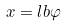Convert formula to latex. <formula><loc_0><loc_0><loc_500><loc_500>x = l b \varphi</formula> 